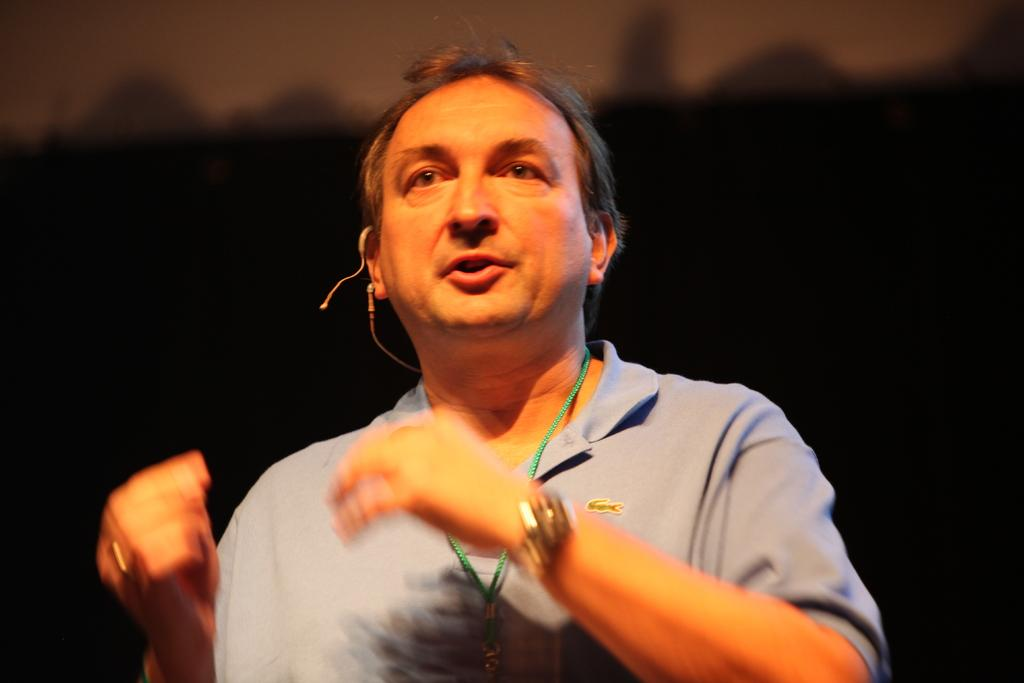What is the main subject of the image? There is a person in the image. Can you describe the background of the image? The background of the image is dark. What type of yarn is the person knitting in the image? There is no yarn or knitting activity present in the image. 